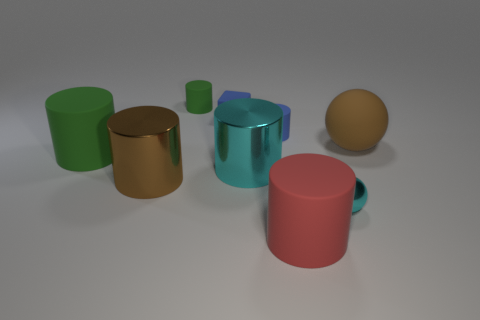Is the number of metal spheres less than the number of large shiny things? Yes, there is only one metal sphere visible, which is less than the number of large shiny objects in the scene. Amongst the items present, several have reflective surfaces that could be classified as 'shiny,' such as the golden cylinder, the teal cup with a handle, and the pink cup. 